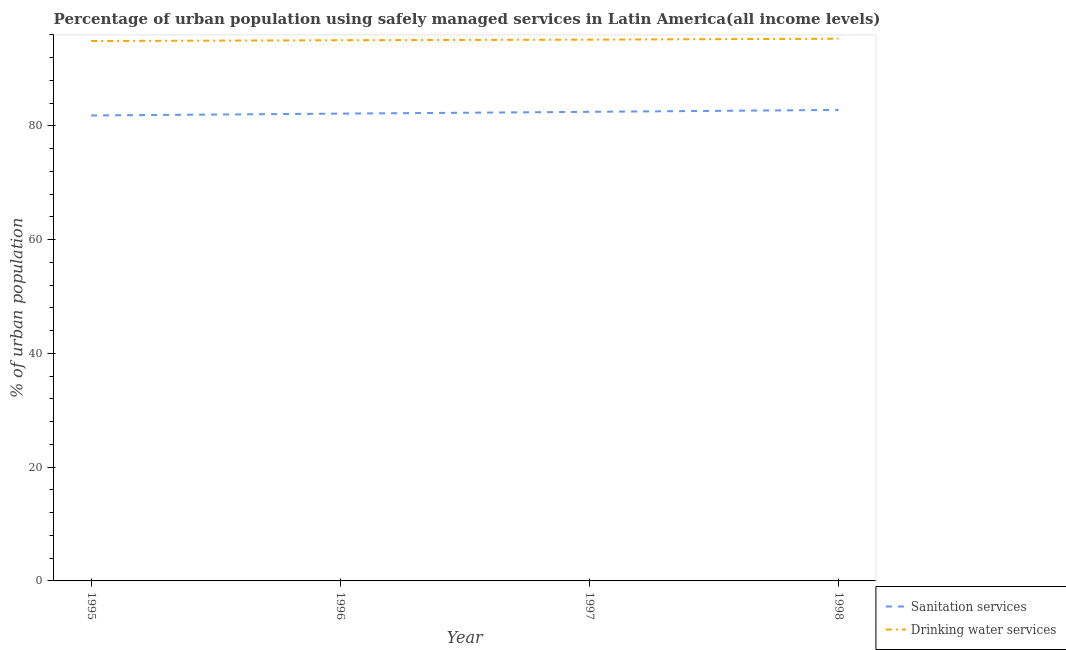Does the line corresponding to percentage of urban population who used sanitation services intersect with the line corresponding to percentage of urban population who used drinking water services?
Keep it short and to the point. No. What is the percentage of urban population who used sanitation services in 1997?
Your answer should be very brief. 82.48. Across all years, what is the maximum percentage of urban population who used drinking water services?
Your answer should be compact. 95.34. Across all years, what is the minimum percentage of urban population who used sanitation services?
Keep it short and to the point. 81.84. What is the total percentage of urban population who used sanitation services in the graph?
Ensure brevity in your answer.  329.3. What is the difference between the percentage of urban population who used sanitation services in 1995 and that in 1997?
Your answer should be very brief. -0.64. What is the difference between the percentage of urban population who used sanitation services in 1996 and the percentage of urban population who used drinking water services in 1995?
Make the answer very short. -12.77. What is the average percentage of urban population who used sanitation services per year?
Offer a very short reply. 82.33. In the year 1997, what is the difference between the percentage of urban population who used drinking water services and percentage of urban population who used sanitation services?
Your answer should be compact. 12.69. What is the ratio of the percentage of urban population who used sanitation services in 1996 to that in 1998?
Offer a very short reply. 0.99. What is the difference between the highest and the second highest percentage of urban population who used drinking water services?
Offer a terse response. 0.17. What is the difference between the highest and the lowest percentage of urban population who used drinking water services?
Your answer should be very brief. 0.4. Is the sum of the percentage of urban population who used sanitation services in 1996 and 1998 greater than the maximum percentage of urban population who used drinking water services across all years?
Your answer should be compact. Yes. Does the percentage of urban population who used drinking water services monotonically increase over the years?
Make the answer very short. Yes. Is the percentage of urban population who used drinking water services strictly greater than the percentage of urban population who used sanitation services over the years?
Offer a very short reply. Yes. Is the percentage of urban population who used drinking water services strictly less than the percentage of urban population who used sanitation services over the years?
Provide a succinct answer. No. How many lines are there?
Give a very brief answer. 2. Does the graph contain any zero values?
Your answer should be very brief. No. Does the graph contain grids?
Keep it short and to the point. No. Where does the legend appear in the graph?
Your answer should be compact. Bottom right. How many legend labels are there?
Your answer should be compact. 2. What is the title of the graph?
Provide a succinct answer. Percentage of urban population using safely managed services in Latin America(all income levels). What is the label or title of the Y-axis?
Offer a very short reply. % of urban population. What is the % of urban population in Sanitation services in 1995?
Provide a short and direct response. 81.84. What is the % of urban population in Drinking water services in 1995?
Offer a very short reply. 94.93. What is the % of urban population in Sanitation services in 1996?
Make the answer very short. 82.16. What is the % of urban population of Drinking water services in 1996?
Provide a succinct answer. 95.07. What is the % of urban population in Sanitation services in 1997?
Offer a very short reply. 82.48. What is the % of urban population of Drinking water services in 1997?
Provide a short and direct response. 95.17. What is the % of urban population in Sanitation services in 1998?
Provide a short and direct response. 82.82. What is the % of urban population in Drinking water services in 1998?
Your response must be concise. 95.34. Across all years, what is the maximum % of urban population of Sanitation services?
Offer a terse response. 82.82. Across all years, what is the maximum % of urban population of Drinking water services?
Your answer should be compact. 95.34. Across all years, what is the minimum % of urban population of Sanitation services?
Make the answer very short. 81.84. Across all years, what is the minimum % of urban population of Drinking water services?
Your answer should be very brief. 94.93. What is the total % of urban population in Sanitation services in the graph?
Your answer should be compact. 329.3. What is the total % of urban population of Drinking water services in the graph?
Your answer should be compact. 380.51. What is the difference between the % of urban population of Sanitation services in 1995 and that in 1996?
Your response must be concise. -0.32. What is the difference between the % of urban population in Drinking water services in 1995 and that in 1996?
Your response must be concise. -0.14. What is the difference between the % of urban population in Sanitation services in 1995 and that in 1997?
Your answer should be compact. -0.64. What is the difference between the % of urban population of Drinking water services in 1995 and that in 1997?
Keep it short and to the point. -0.24. What is the difference between the % of urban population in Sanitation services in 1995 and that in 1998?
Offer a very short reply. -0.98. What is the difference between the % of urban population of Drinking water services in 1995 and that in 1998?
Keep it short and to the point. -0.4. What is the difference between the % of urban population in Sanitation services in 1996 and that in 1997?
Make the answer very short. -0.31. What is the difference between the % of urban population in Drinking water services in 1996 and that in 1997?
Your answer should be very brief. -0.1. What is the difference between the % of urban population in Sanitation services in 1996 and that in 1998?
Provide a short and direct response. -0.65. What is the difference between the % of urban population in Drinking water services in 1996 and that in 1998?
Provide a short and direct response. -0.27. What is the difference between the % of urban population of Sanitation services in 1997 and that in 1998?
Your response must be concise. -0.34. What is the difference between the % of urban population of Drinking water services in 1997 and that in 1998?
Give a very brief answer. -0.17. What is the difference between the % of urban population of Sanitation services in 1995 and the % of urban population of Drinking water services in 1996?
Keep it short and to the point. -13.23. What is the difference between the % of urban population of Sanitation services in 1995 and the % of urban population of Drinking water services in 1997?
Offer a very short reply. -13.33. What is the difference between the % of urban population in Sanitation services in 1995 and the % of urban population in Drinking water services in 1998?
Provide a short and direct response. -13.49. What is the difference between the % of urban population of Sanitation services in 1996 and the % of urban population of Drinking water services in 1997?
Your answer should be compact. -13. What is the difference between the % of urban population of Sanitation services in 1996 and the % of urban population of Drinking water services in 1998?
Offer a very short reply. -13.17. What is the difference between the % of urban population of Sanitation services in 1997 and the % of urban population of Drinking water services in 1998?
Keep it short and to the point. -12.86. What is the average % of urban population of Sanitation services per year?
Give a very brief answer. 82.33. What is the average % of urban population of Drinking water services per year?
Provide a short and direct response. 95.13. In the year 1995, what is the difference between the % of urban population in Sanitation services and % of urban population in Drinking water services?
Give a very brief answer. -13.09. In the year 1996, what is the difference between the % of urban population in Sanitation services and % of urban population in Drinking water services?
Your answer should be compact. -12.91. In the year 1997, what is the difference between the % of urban population of Sanitation services and % of urban population of Drinking water services?
Make the answer very short. -12.69. In the year 1998, what is the difference between the % of urban population of Sanitation services and % of urban population of Drinking water services?
Your answer should be very brief. -12.52. What is the ratio of the % of urban population of Drinking water services in 1995 to that in 1996?
Your response must be concise. 1. What is the ratio of the % of urban population of Drinking water services in 1995 to that in 1997?
Provide a short and direct response. 1. What is the ratio of the % of urban population of Sanitation services in 1995 to that in 1998?
Provide a short and direct response. 0.99. What is the ratio of the % of urban population of Drinking water services in 1995 to that in 1998?
Give a very brief answer. 1. What is the ratio of the % of urban population of Sanitation services in 1996 to that in 1997?
Your answer should be compact. 1. What is the ratio of the % of urban population of Drinking water services in 1996 to that in 1998?
Provide a short and direct response. 1. What is the difference between the highest and the second highest % of urban population in Sanitation services?
Provide a short and direct response. 0.34. What is the difference between the highest and the second highest % of urban population in Drinking water services?
Provide a succinct answer. 0.17. What is the difference between the highest and the lowest % of urban population of Drinking water services?
Offer a very short reply. 0.4. 